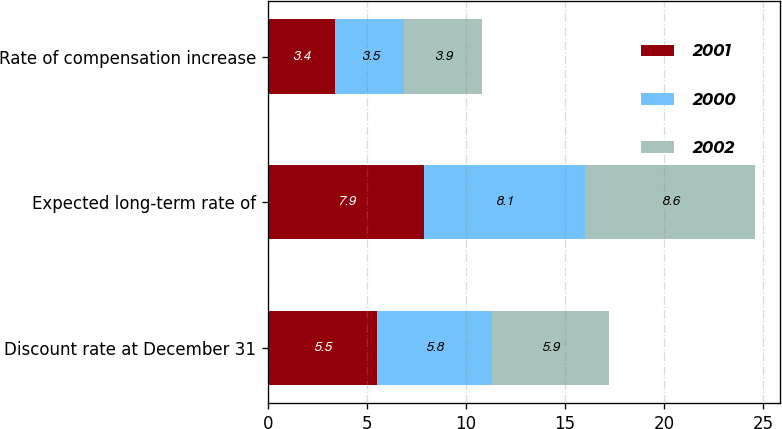Convert chart to OTSL. <chart><loc_0><loc_0><loc_500><loc_500><stacked_bar_chart><ecel><fcel>Discount rate at December 31<fcel>Expected long-term rate of<fcel>Rate of compensation increase<nl><fcel>2001<fcel>5.5<fcel>7.9<fcel>3.4<nl><fcel>2000<fcel>5.8<fcel>8.1<fcel>3.5<nl><fcel>2002<fcel>5.9<fcel>8.6<fcel>3.9<nl></chart> 